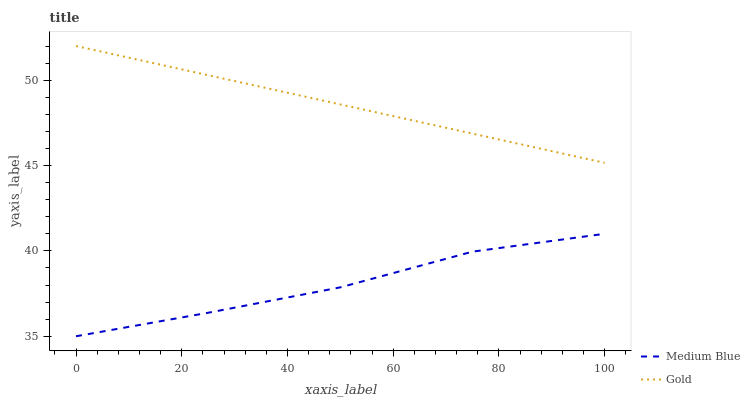Does Medium Blue have the minimum area under the curve?
Answer yes or no. Yes. Does Gold have the maximum area under the curve?
Answer yes or no. Yes. Does Gold have the minimum area under the curve?
Answer yes or no. No. Is Gold the smoothest?
Answer yes or no. Yes. Is Medium Blue the roughest?
Answer yes or no. Yes. Is Gold the roughest?
Answer yes or no. No. Does Gold have the lowest value?
Answer yes or no. No. Is Medium Blue less than Gold?
Answer yes or no. Yes. Is Gold greater than Medium Blue?
Answer yes or no. Yes. Does Medium Blue intersect Gold?
Answer yes or no. No. 